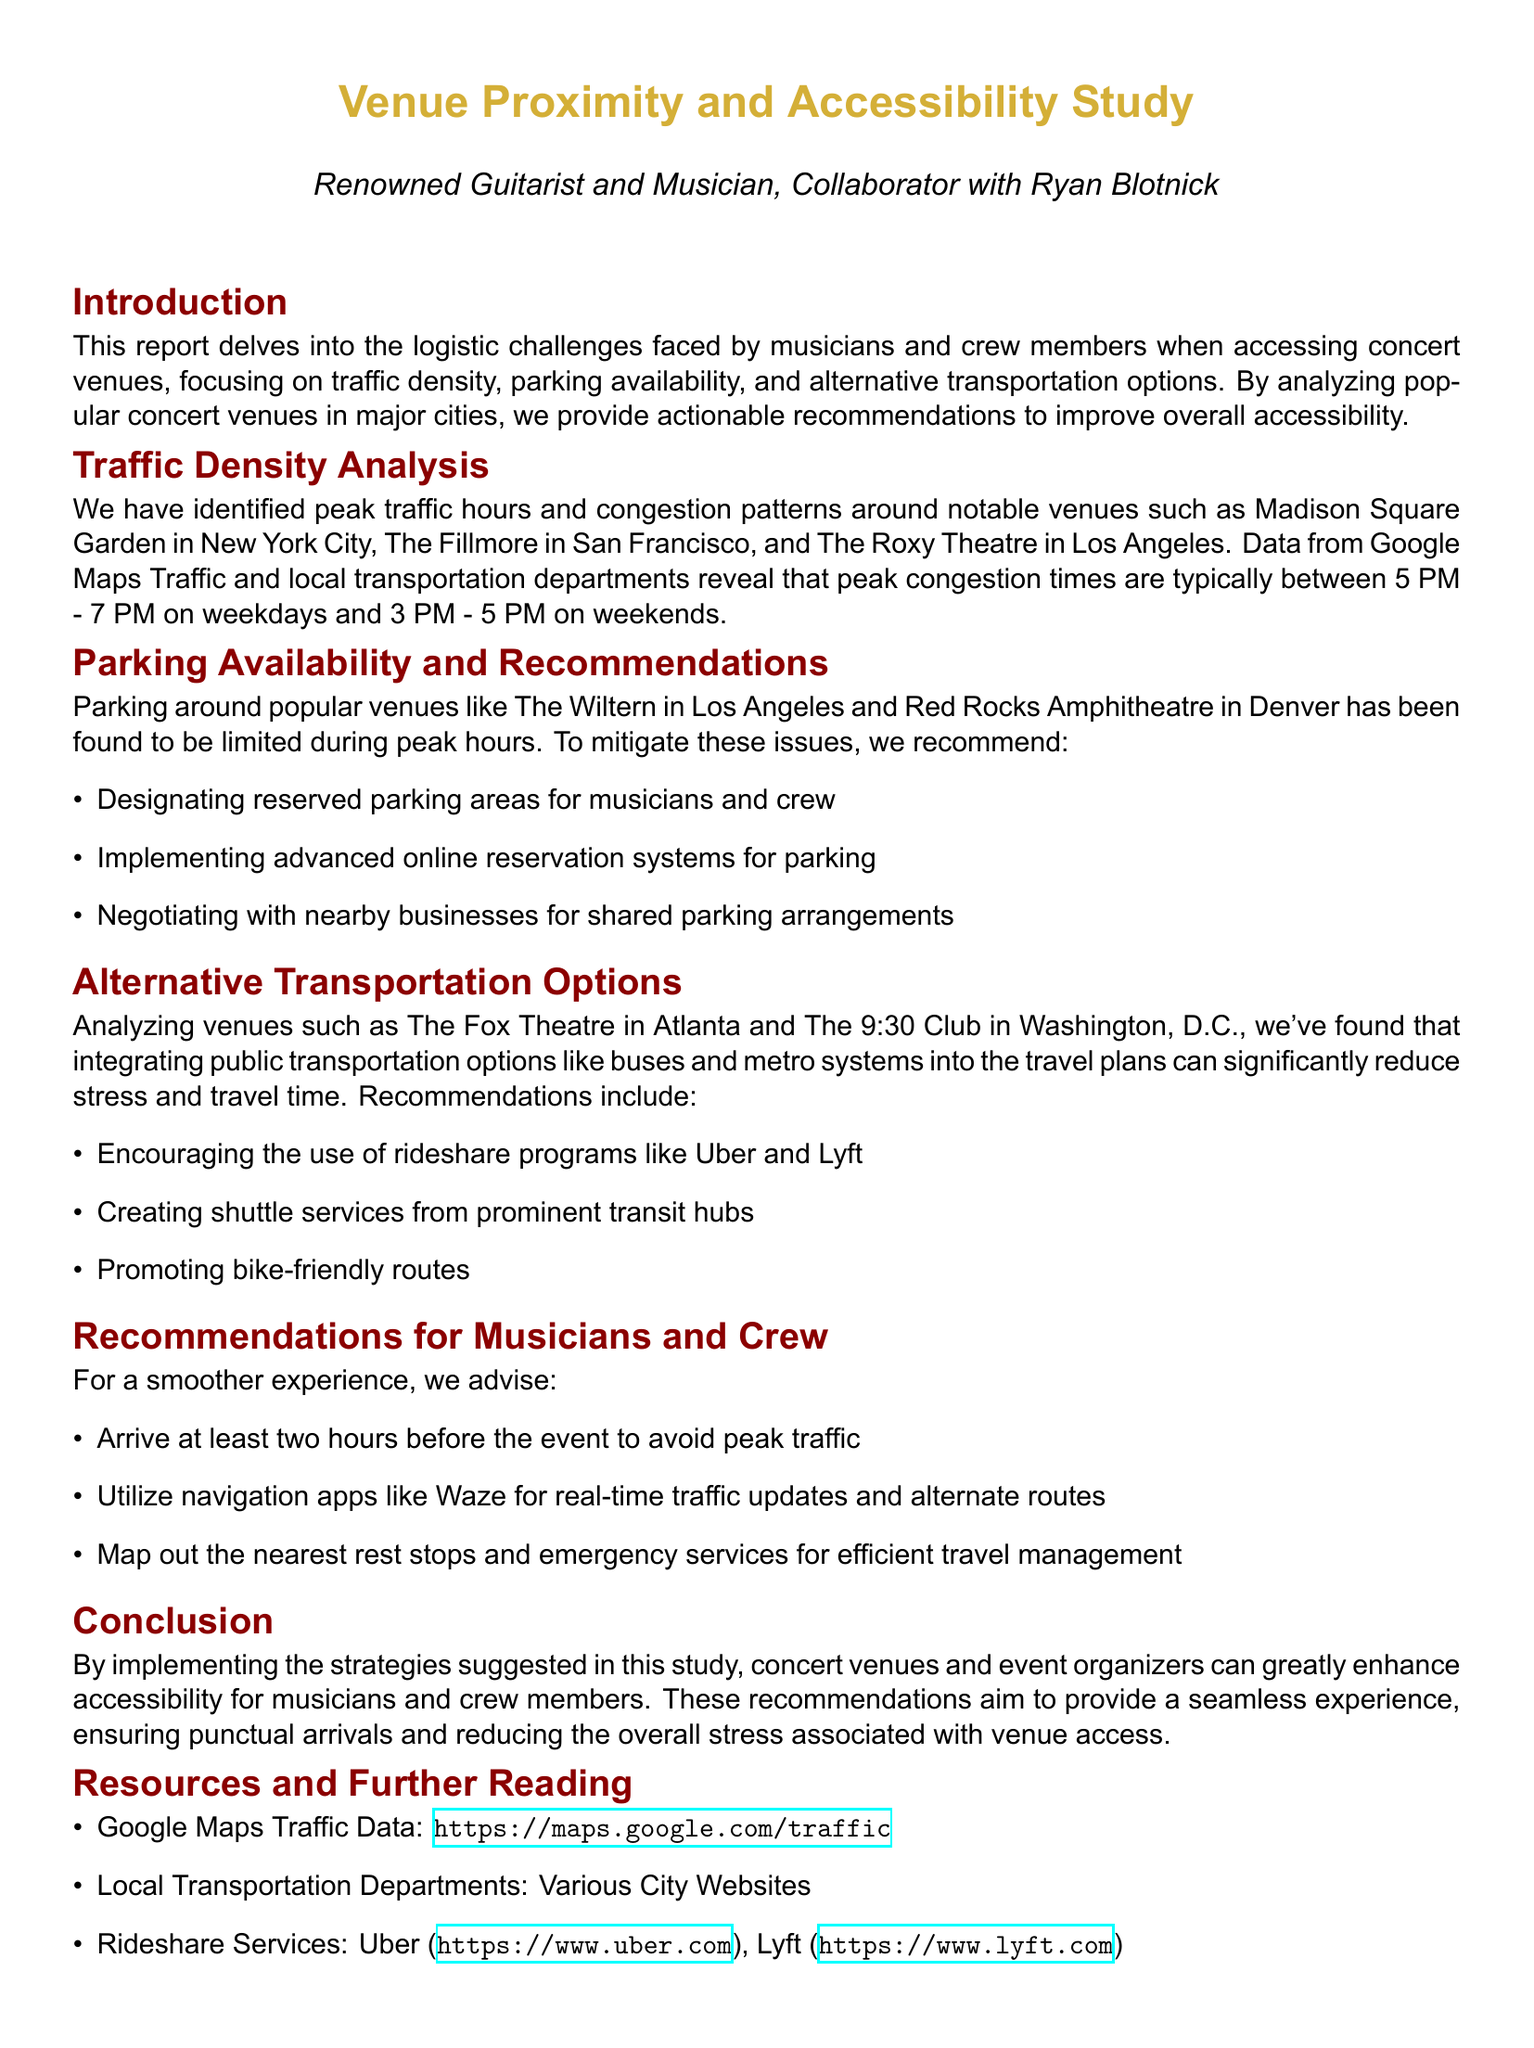What are the peak traffic hours on weekdays? The document states that peak congestion times are typically between 5 PM - 7 PM on weekdays.
Answer: 5 PM - 7 PM Which venue is highlighted in connection with Denver? The document mentions Red Rocks Amphitheatre in Denver as a venue with limited parking.
Answer: Red Rocks Amphitheatre What recommendation is made for parking arrangements? The report recommends negotiating with nearby businesses for shared parking arrangements.
Answer: Shared parking arrangements What alternative transportation option is mentioned for reducing travel stress? The document suggests encouraging the use of rideshare programs like Uber and Lyft.
Answer: Rideshare programs What is advised for musicians regarding event arrival? The report advises musicians to arrive at least two hours before the event.
Answer: Two hours Which city is associated with The Fox Theatre? The Fox Theatre is located in Atlanta.
Answer: Atlanta What time are peak traffic hours on weekends? The document notes that peak congestion times on weekends are typically between 3 PM - 5 PM.
Answer: 3 PM - 5 PM What tool is recommended for real-time traffic updates? The report recommends using navigation apps like Waze for real-time traffic updates.
Answer: Waze 